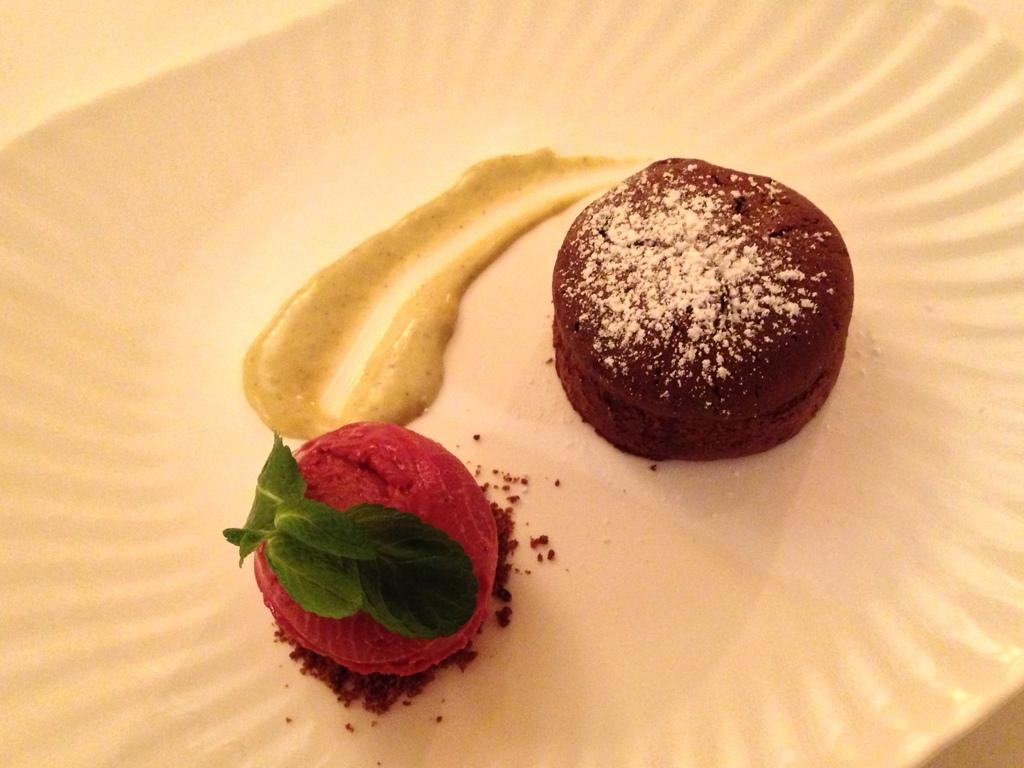What is on the plate in the image? There is food in a plate in the image. What is covering the food on the plate? There are green leaves on top of the food. Where is the plate located in the image? The plate is placed on a surface. How much mass does the mine have in the image? There is no mine present in the image, so it is not possible to determine its mass. 